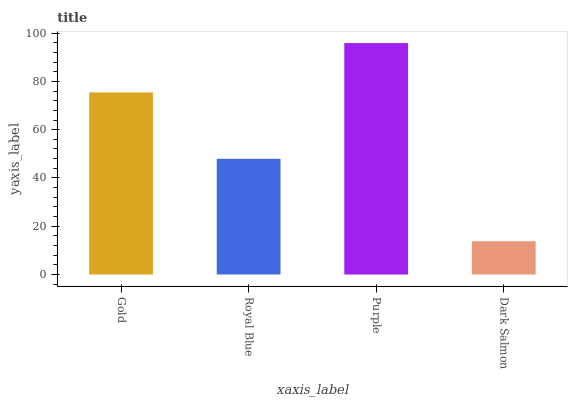Is Royal Blue the minimum?
Answer yes or no. No. Is Royal Blue the maximum?
Answer yes or no. No. Is Gold greater than Royal Blue?
Answer yes or no. Yes. Is Royal Blue less than Gold?
Answer yes or no. Yes. Is Royal Blue greater than Gold?
Answer yes or no. No. Is Gold less than Royal Blue?
Answer yes or no. No. Is Gold the high median?
Answer yes or no. Yes. Is Royal Blue the low median?
Answer yes or no. Yes. Is Royal Blue the high median?
Answer yes or no. No. Is Purple the low median?
Answer yes or no. No. 